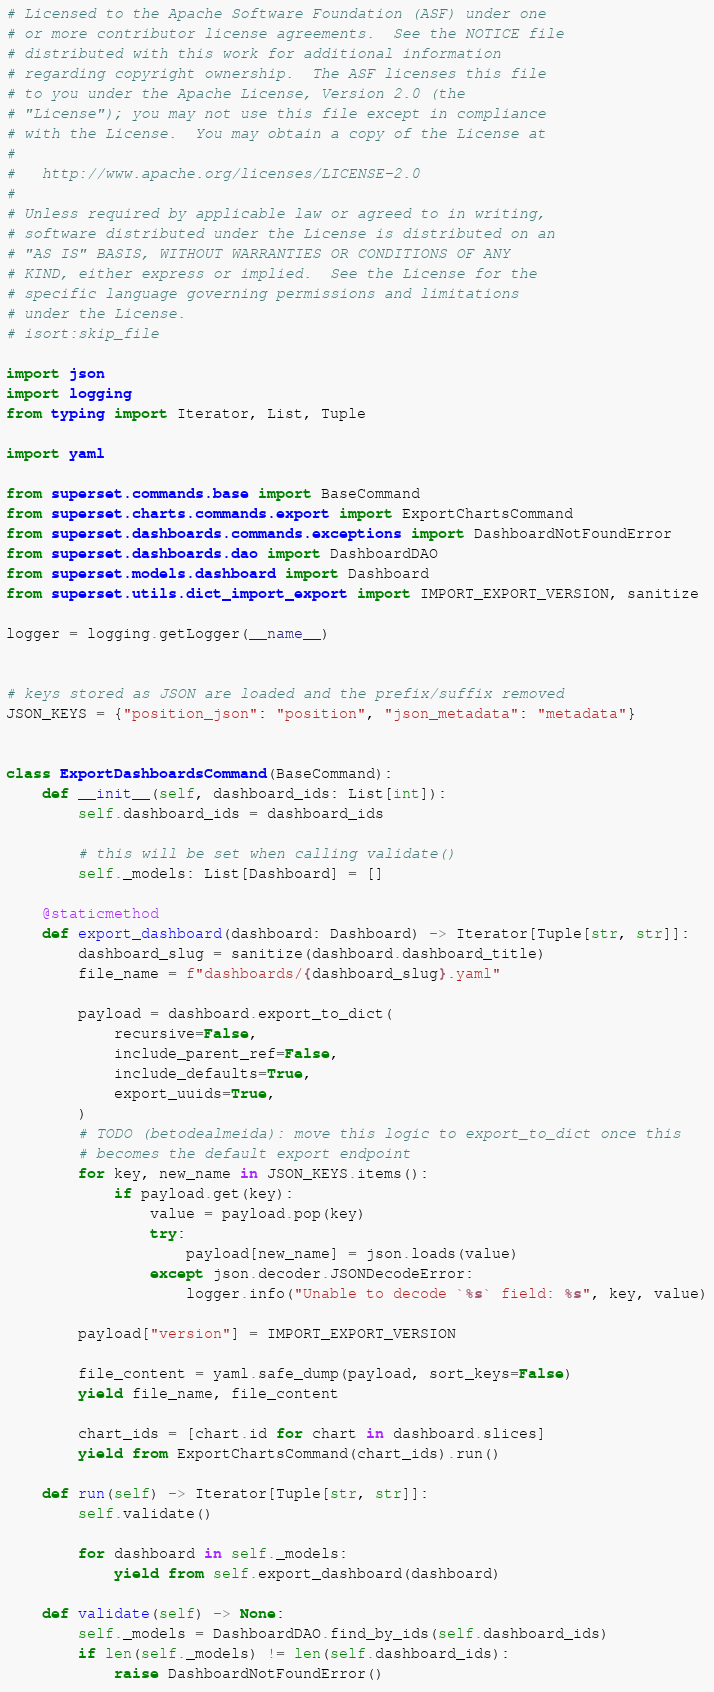<code> <loc_0><loc_0><loc_500><loc_500><_Python_># Licensed to the Apache Software Foundation (ASF) under one
# or more contributor license agreements.  See the NOTICE file
# distributed with this work for additional information
# regarding copyright ownership.  The ASF licenses this file
# to you under the Apache License, Version 2.0 (the
# "License"); you may not use this file except in compliance
# with the License.  You may obtain a copy of the License at
#
#   http://www.apache.org/licenses/LICENSE-2.0
#
# Unless required by applicable law or agreed to in writing,
# software distributed under the License is distributed on an
# "AS IS" BASIS, WITHOUT WARRANTIES OR CONDITIONS OF ANY
# KIND, either express or implied.  See the License for the
# specific language governing permissions and limitations
# under the License.
# isort:skip_file

import json
import logging
from typing import Iterator, List, Tuple

import yaml

from superset.commands.base import BaseCommand
from superset.charts.commands.export import ExportChartsCommand
from superset.dashboards.commands.exceptions import DashboardNotFoundError
from superset.dashboards.dao import DashboardDAO
from superset.models.dashboard import Dashboard
from superset.utils.dict_import_export import IMPORT_EXPORT_VERSION, sanitize

logger = logging.getLogger(__name__)


# keys stored as JSON are loaded and the prefix/suffix removed
JSON_KEYS = {"position_json": "position", "json_metadata": "metadata"}


class ExportDashboardsCommand(BaseCommand):
    def __init__(self, dashboard_ids: List[int]):
        self.dashboard_ids = dashboard_ids

        # this will be set when calling validate()
        self._models: List[Dashboard] = []

    @staticmethod
    def export_dashboard(dashboard: Dashboard) -> Iterator[Tuple[str, str]]:
        dashboard_slug = sanitize(dashboard.dashboard_title)
        file_name = f"dashboards/{dashboard_slug}.yaml"

        payload = dashboard.export_to_dict(
            recursive=False,
            include_parent_ref=False,
            include_defaults=True,
            export_uuids=True,
        )
        # TODO (betodealmeida): move this logic to export_to_dict once this
        # becomes the default export endpoint
        for key, new_name in JSON_KEYS.items():
            if payload.get(key):
                value = payload.pop(key)
                try:
                    payload[new_name] = json.loads(value)
                except json.decoder.JSONDecodeError:
                    logger.info("Unable to decode `%s` field: %s", key, value)

        payload["version"] = IMPORT_EXPORT_VERSION

        file_content = yaml.safe_dump(payload, sort_keys=False)
        yield file_name, file_content

        chart_ids = [chart.id for chart in dashboard.slices]
        yield from ExportChartsCommand(chart_ids).run()

    def run(self) -> Iterator[Tuple[str, str]]:
        self.validate()

        for dashboard in self._models:
            yield from self.export_dashboard(dashboard)

    def validate(self) -> None:
        self._models = DashboardDAO.find_by_ids(self.dashboard_ids)
        if len(self._models) != len(self.dashboard_ids):
            raise DashboardNotFoundError()
</code> 